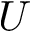Convert formula to latex. <formula><loc_0><loc_0><loc_500><loc_500>U</formula> 